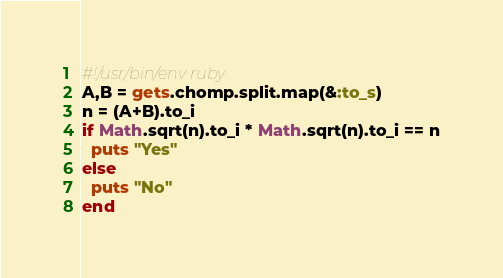Convert code to text. <code><loc_0><loc_0><loc_500><loc_500><_Ruby_>#!/usr/bin/env ruby
A,B = gets.chomp.split.map(&:to_s)
n = (A+B).to_i
if Math.sqrt(n).to_i * Math.sqrt(n).to_i == n
  puts "Yes"
else
  puts "No"
end</code> 